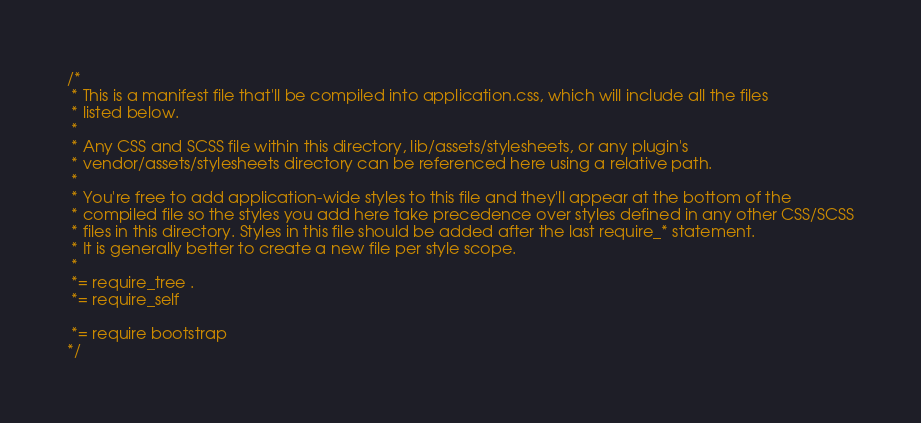Convert code to text. <code><loc_0><loc_0><loc_500><loc_500><_CSS_>/*
 * This is a manifest file that'll be compiled into application.css, which will include all the files
 * listed below.
 *
 * Any CSS and SCSS file within this directory, lib/assets/stylesheets, or any plugin's
 * vendor/assets/stylesheets directory can be referenced here using a relative path.
 *
 * You're free to add application-wide styles to this file and they'll appear at the bottom of the
 * compiled file so the styles you add here take precedence over styles defined in any other CSS/SCSS
 * files in this directory. Styles in this file should be added after the last require_* statement.
 * It is generally better to create a new file per style scope.
 *
 *= require_tree .
 *= require_self

 *= require bootstrap
*/</code> 